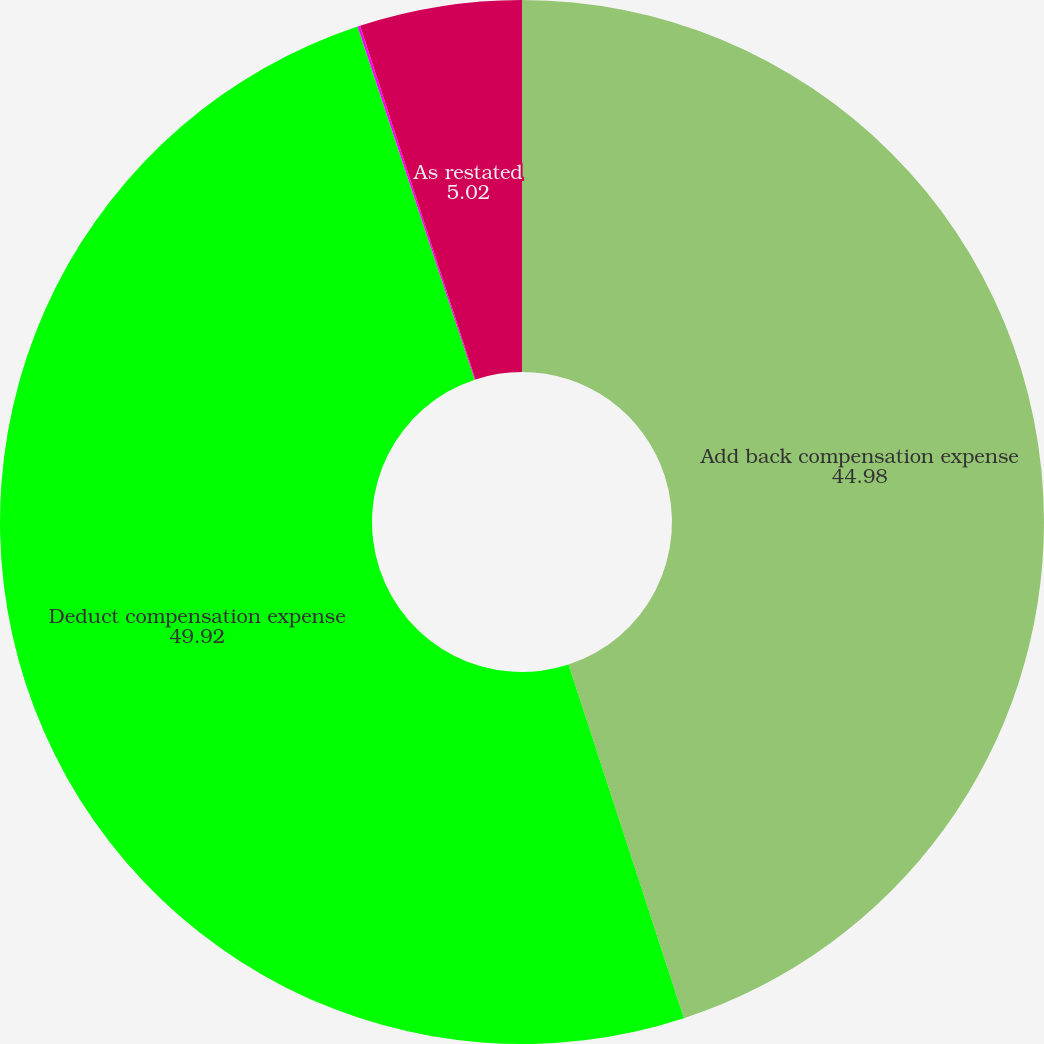Convert chart to OTSL. <chart><loc_0><loc_0><loc_500><loc_500><pie_chart><fcel>Add back compensation expense<fcel>Deduct compensation expense<fcel>As previously reported<fcel>As restated<nl><fcel>44.98%<fcel>49.92%<fcel>0.08%<fcel>5.02%<nl></chart> 